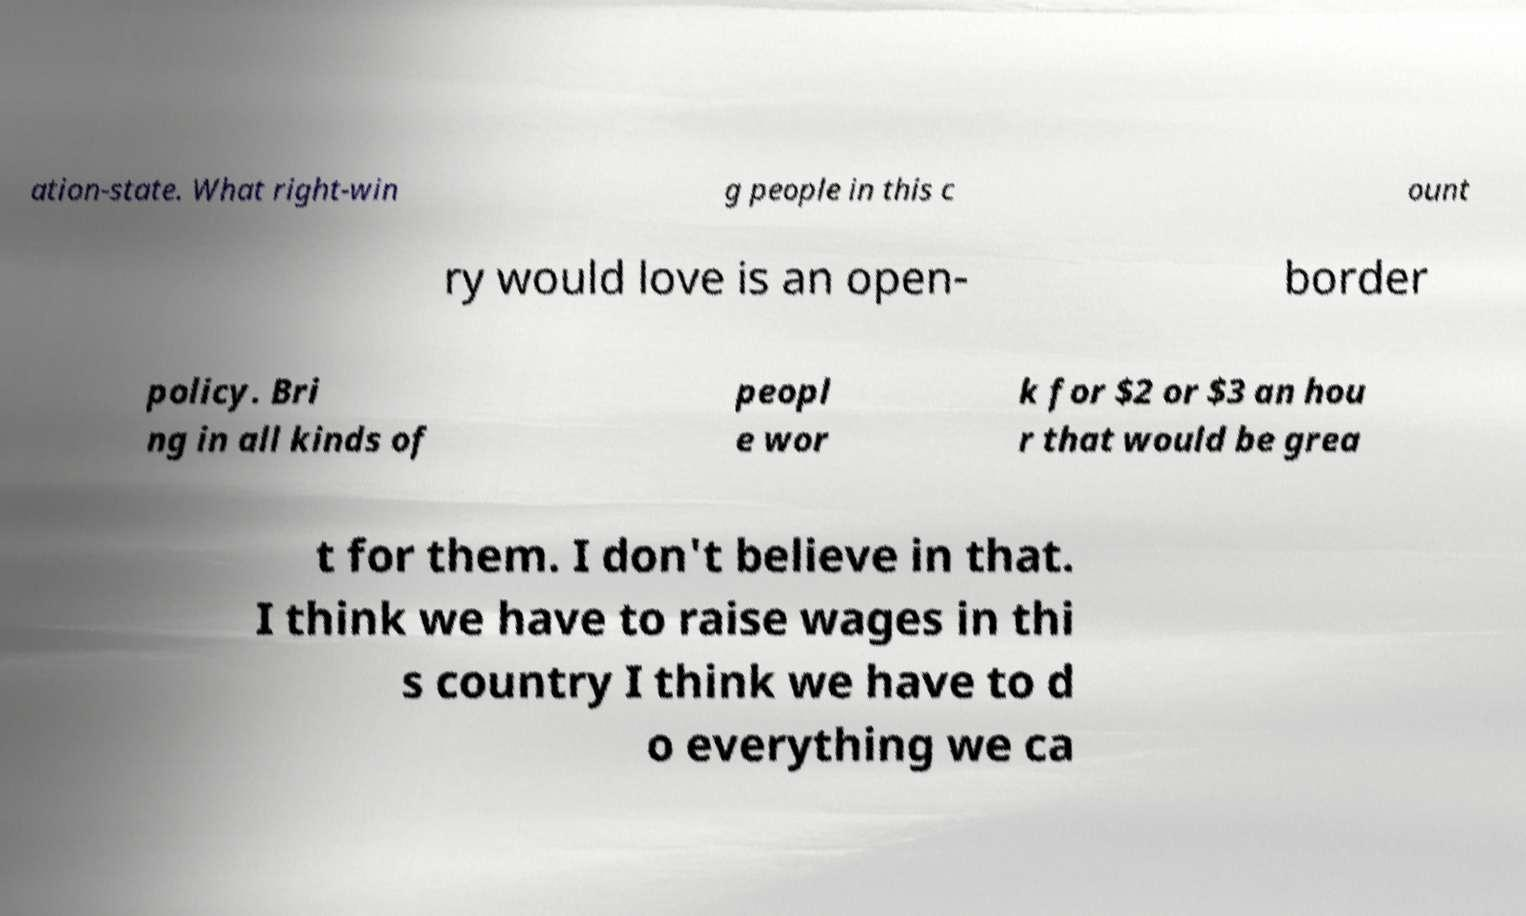Can you accurately transcribe the text from the provided image for me? ation-state. What right-win g people in this c ount ry would love is an open- border policy. Bri ng in all kinds of peopl e wor k for $2 or $3 an hou r that would be grea t for them. I don't believe in that. I think we have to raise wages in thi s country I think we have to d o everything we ca 